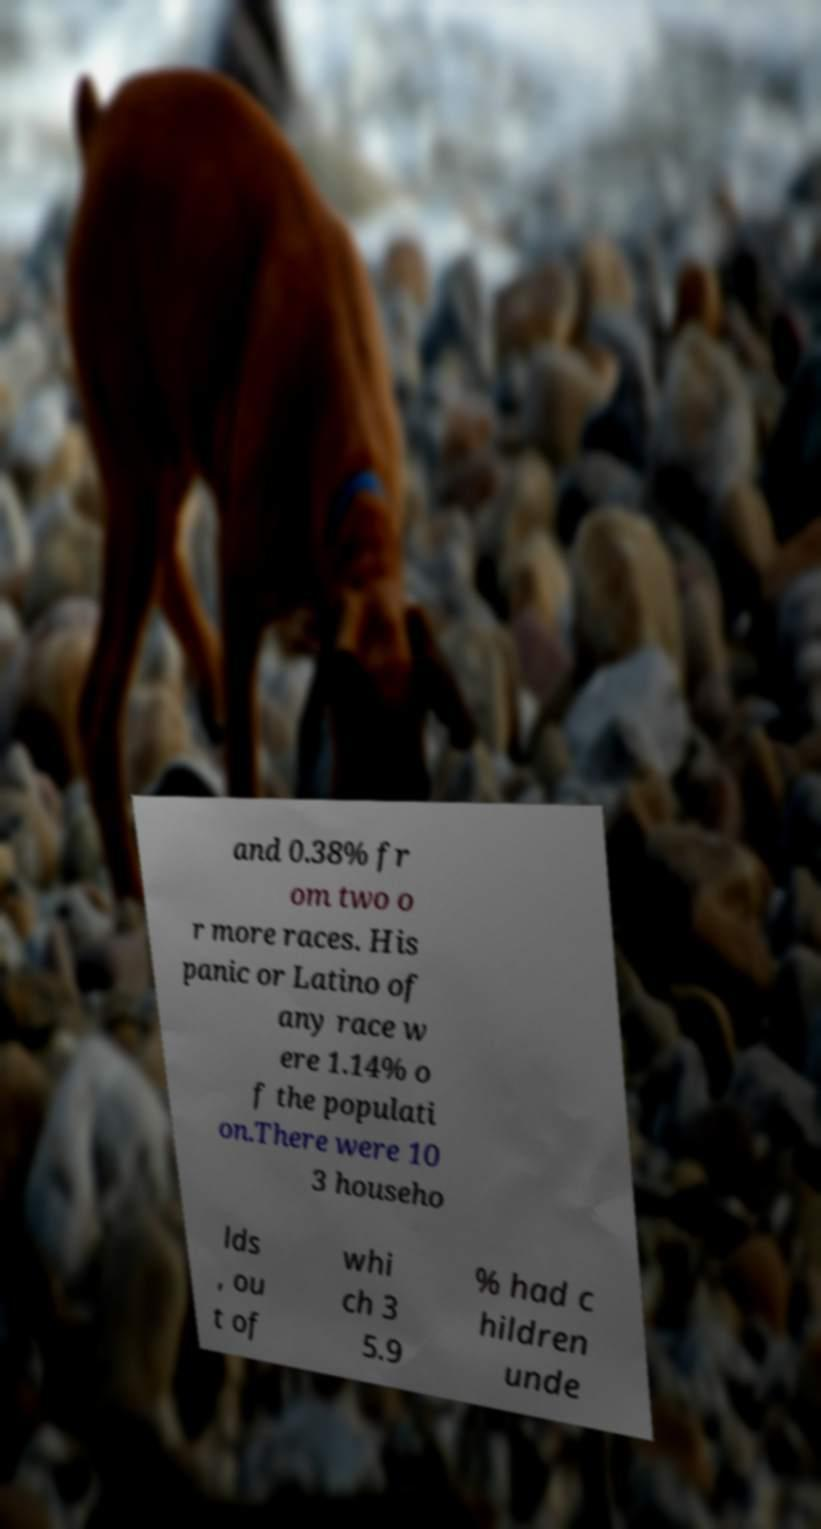There's text embedded in this image that I need extracted. Can you transcribe it verbatim? and 0.38% fr om two o r more races. His panic or Latino of any race w ere 1.14% o f the populati on.There were 10 3 househo lds , ou t of whi ch 3 5.9 % had c hildren unde 